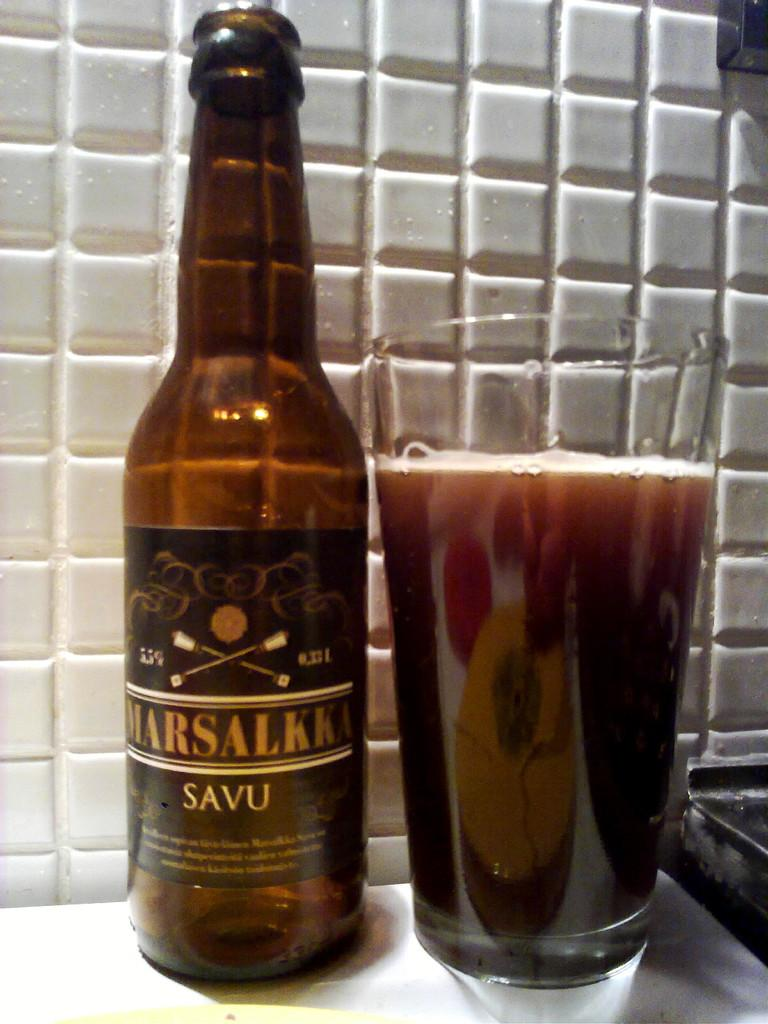<image>
Summarize the visual content of the image. A bottle of Marsalkka Savu sits near a full glass. 